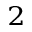Convert formula to latex. <formula><loc_0><loc_0><loc_500><loc_500>_ { 2 }</formula> 